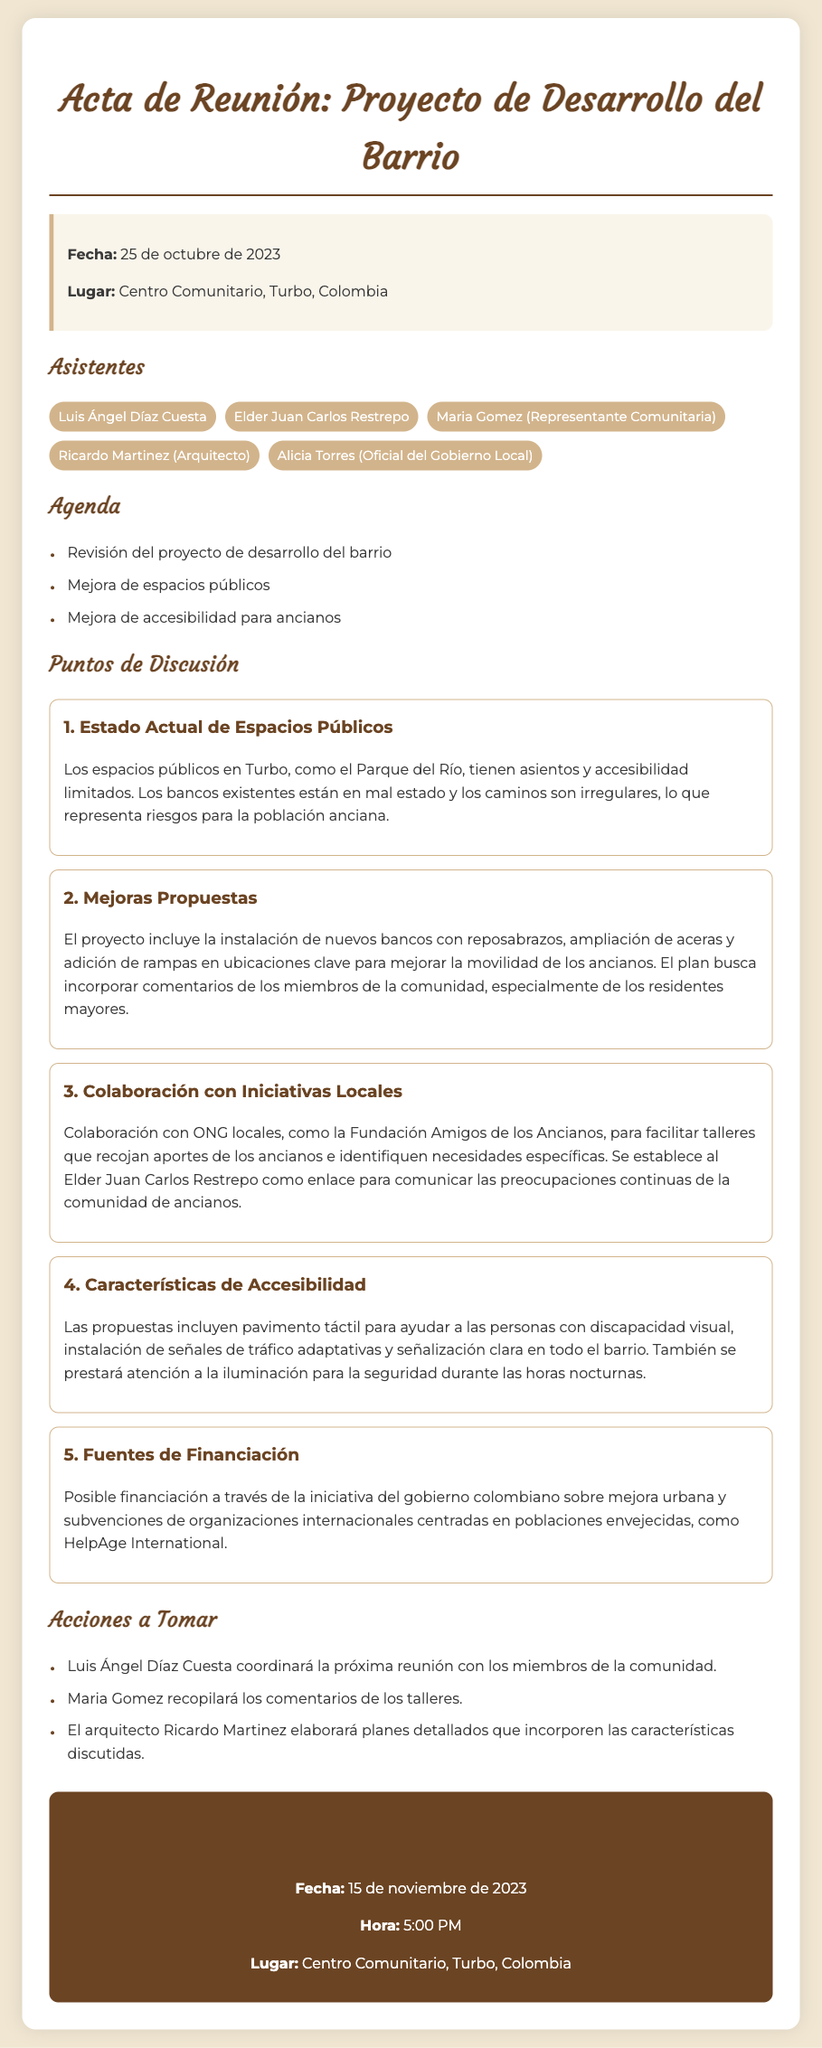¿Qué fecha se llevó a cabo la reunión? La fecha de la reunión está claramente indicada en el documento.
Answer: 25 de octubre de 2023 ¿Quién representa a la comunidad en la reunión? El documento menciona a Maria Gomez como representante comunitaria.
Answer: Maria Gomez ¿Cuál es el lugar de la próxima reunión? El documento especifica el lugar de la próxima reunión.
Answer: Centro Comunitario, Turbo, Colombia ¿Qué se va a instalar para ayudar a la movilidad de los ancianos? Se menciona en el documento que se instalarán nuevos bancos con reposabrazos.
Answer: Nuevos bancos con reposabrazos ¿Cuál es el nombre de la ONG local mencionada en la reunión? El documento hace referencia a una ONG que colabora en el proyecto.
Answer: Fundación Amigos de los Ancianos ¿Qué tipo de pavimento se propone para las personas con discapacidad visual? En el documento se especifica un tipo de pavimento para ayudar a personas con discapacidades.
Answer: Pavimento táctil ¿Cuándo es la próxima reunión programada? La fecha de la próxima reunión se menciona en el documento.
Answer: 15 de noviembre de 2023 ¿Qué arquitecto está a cargo de elaborar los planes detallados? El documento indica el nombre del arquitecto que llevará a cabo esta tarea.
Answer: Ricardo Martinez ¿Qué se priorizará en términos de iluminación según las propuestas? El documento hace énfasis en un aspecto específico de la iluminación.
Answer: Seguridad durante las horas nocturnas 